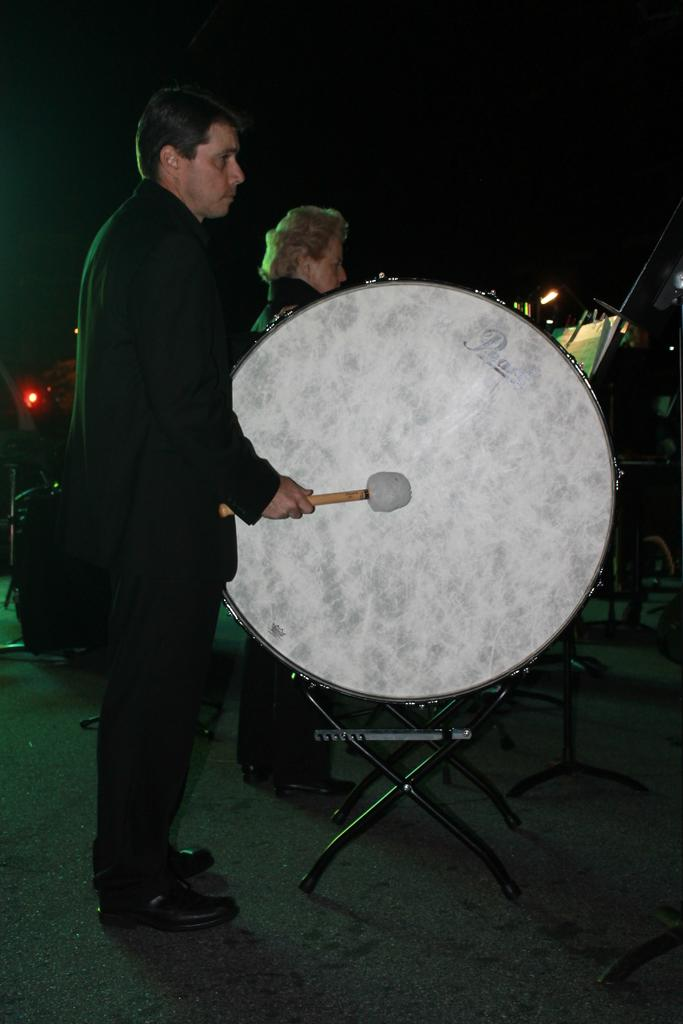What is the person on the left side of the image doing? The person on the left side is playing a drum. What instrument is the person on the left side using? The person on the left side is using a drumstick. How many people are visible in the image? There are two people visible in the image. What type of powder is being used by the person on the right side of the image? There is no person on the right side of the image, and no powder is visible in the image. 